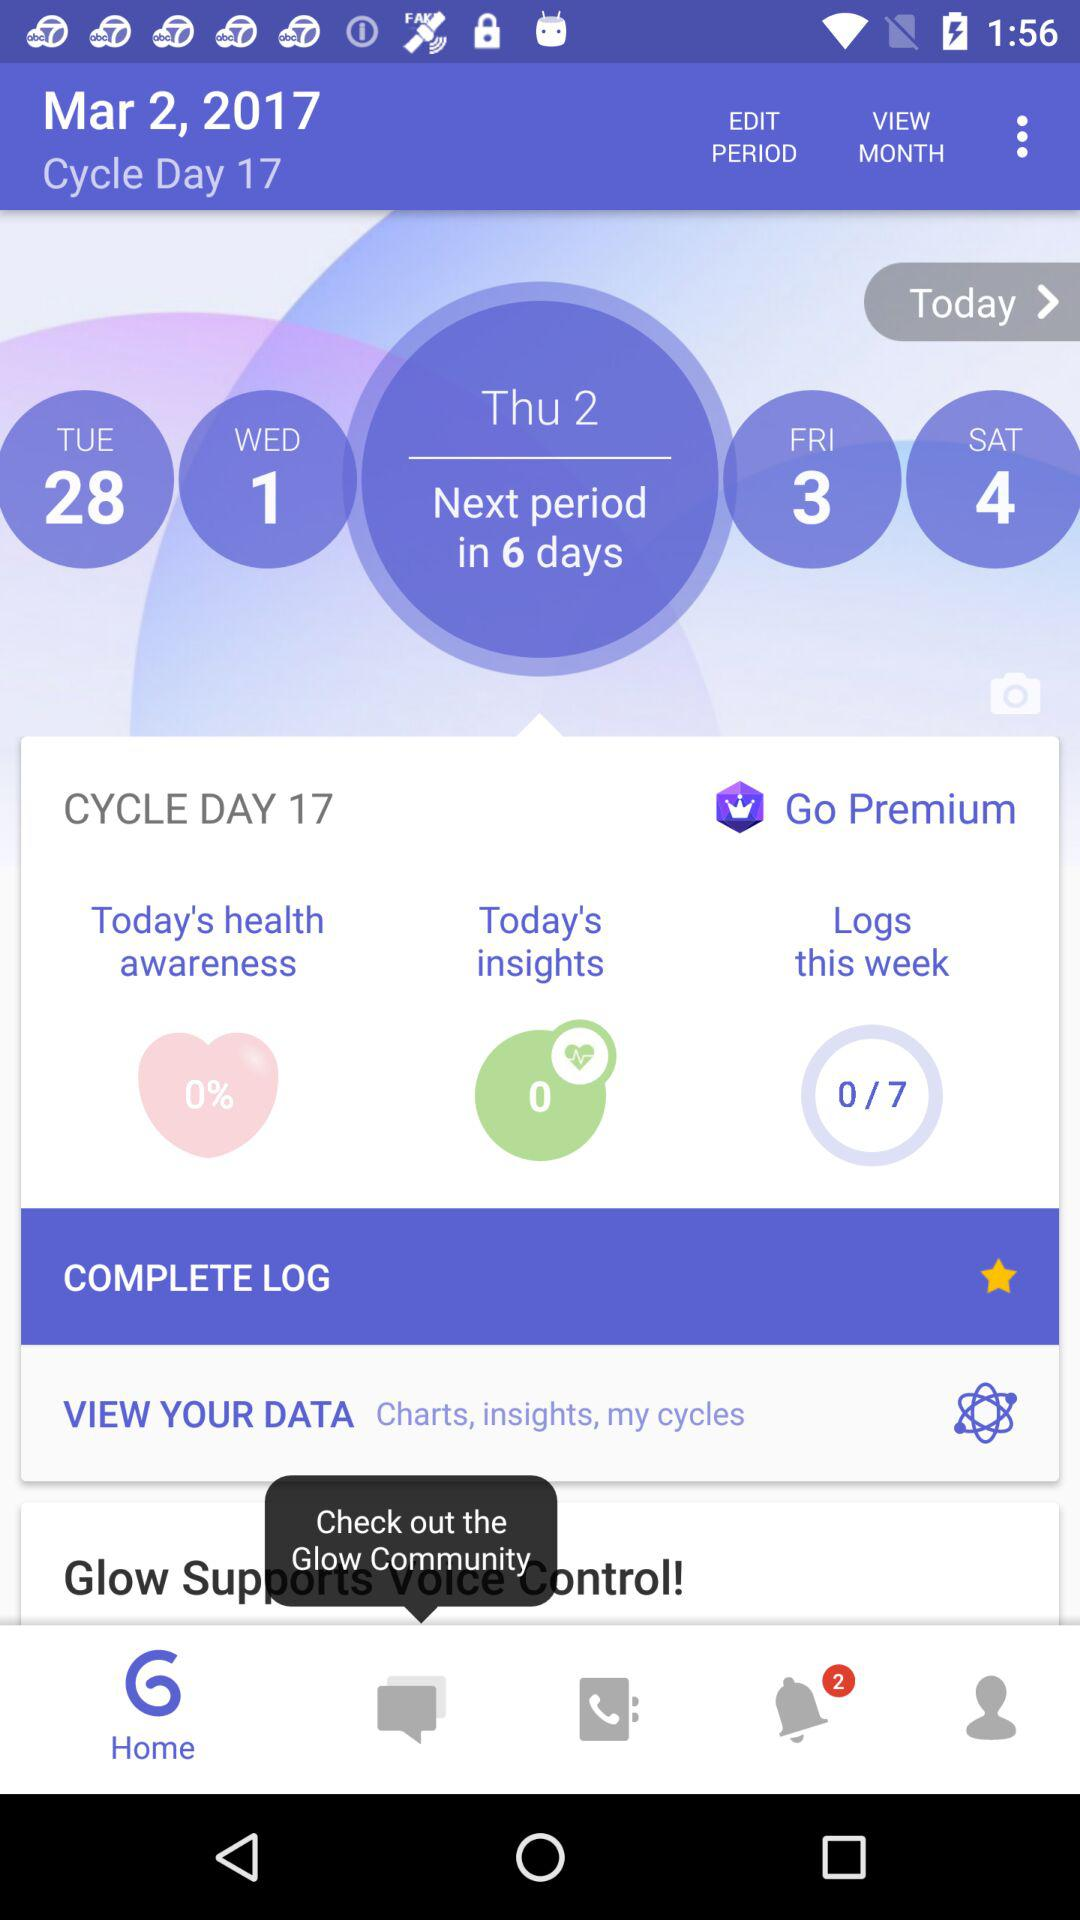How many days until next period?
Answer the question using a single word or phrase. 6 days 